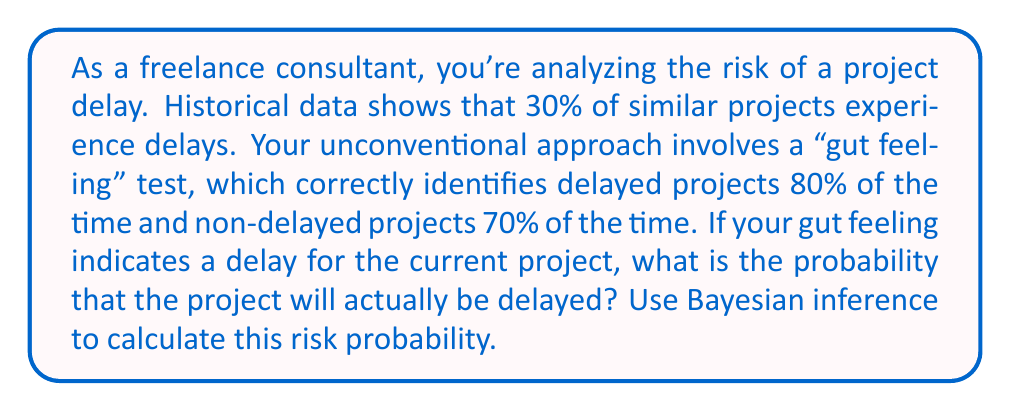Give your solution to this math problem. Let's approach this step-by-step using Bayesian inference:

1) Define our events:
   A: The project is actually delayed
   B: Your gut feeling indicates a delay

2) Given probabilities:
   P(A) = 0.30 (prior probability of delay)
   P(B|A) = 0.80 (probability of gut feeling given actual delay)
   P(B|not A) = 0.30 (probability of gut feeling given no delay)

3) We want to find P(A|B) using Bayes' theorem:

   $$P(A|B) = \frac{P(B|A) \cdot P(A)}{P(B)}$$

4) Calculate P(B) using the law of total probability:
   $$P(B) = P(B|A) \cdot P(A) + P(B|not A) \cdot P(not A)$$
   $$P(B) = 0.80 \cdot 0.30 + 0.30 \cdot 0.70 = 0.24 + 0.21 = 0.45$$

5) Now we can apply Bayes' theorem:

   $$P(A|B) = \frac{0.80 \cdot 0.30}{0.45} = \frac{0.24}{0.45} = \frac{8}{15} \approx 0.5333$$

6) Convert to a percentage: 0.5333 * 100% = 53.33%

Therefore, if your gut feeling indicates a delay, there is a 53.33% probability that the project will actually be delayed.
Answer: 53.33% 